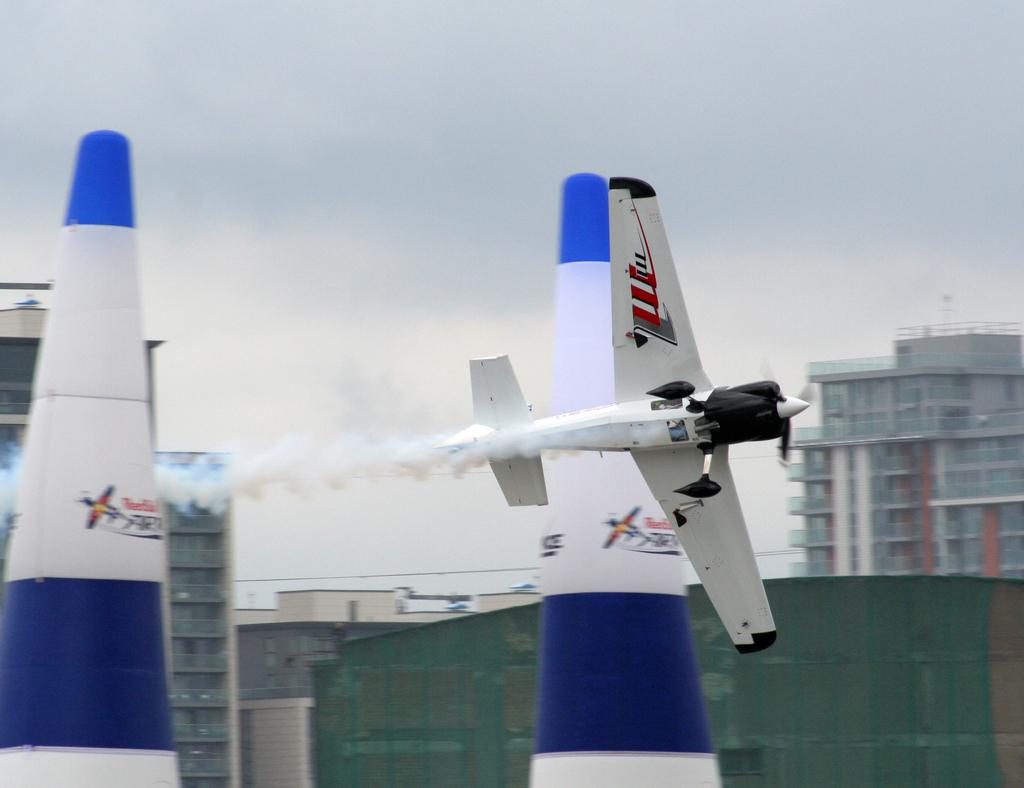What is the main subject of the image? The main subject of the image is an airplane. What is the airplane doing in the image? The airplane is flying in the air. What else can be seen in the image besides the airplane? There are objects and buildings in the image. What is visible at the top of the image? The sky is visible at the top of the image. What type of silk is being used to make the airplane's wings in the image? There is no silk present in the image, and the airplane's wings are not made of silk. 